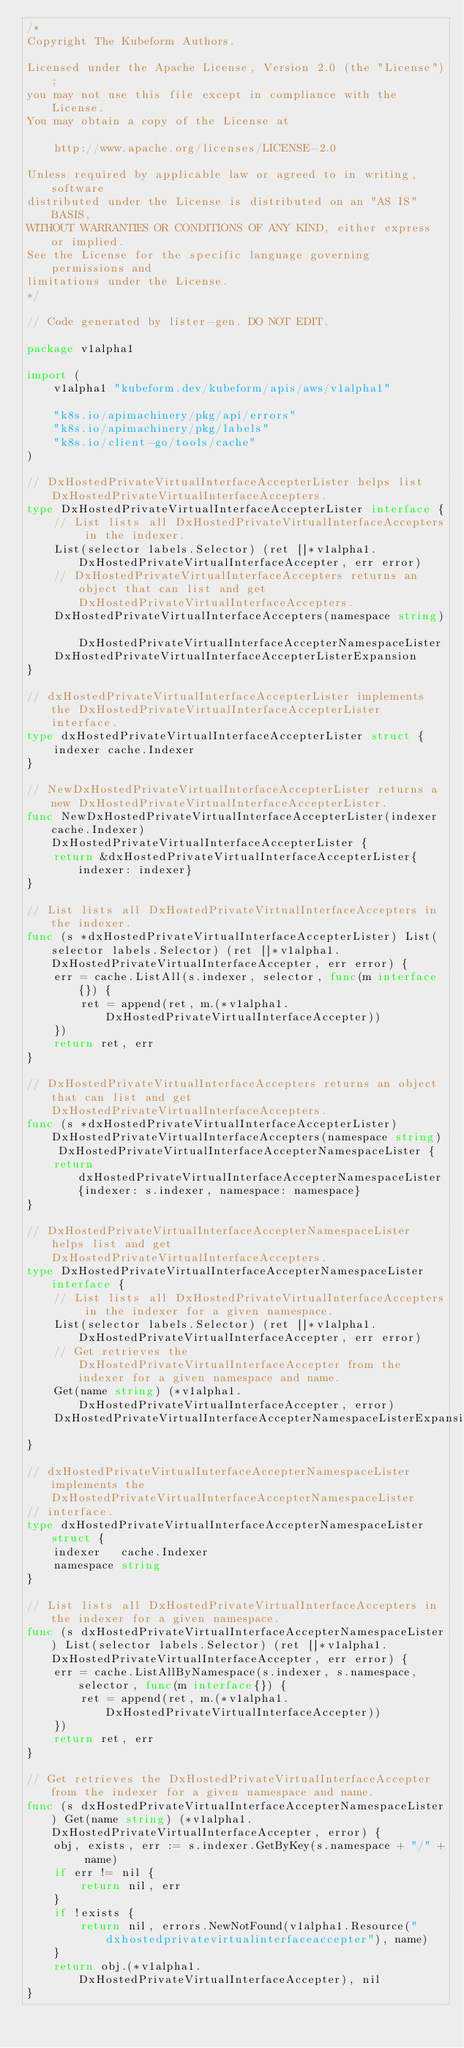<code> <loc_0><loc_0><loc_500><loc_500><_Go_>/*
Copyright The Kubeform Authors.

Licensed under the Apache License, Version 2.0 (the "License");
you may not use this file except in compliance with the License.
You may obtain a copy of the License at

    http://www.apache.org/licenses/LICENSE-2.0

Unless required by applicable law or agreed to in writing, software
distributed under the License is distributed on an "AS IS" BASIS,
WITHOUT WARRANTIES OR CONDITIONS OF ANY KIND, either express or implied.
See the License for the specific language governing permissions and
limitations under the License.
*/

// Code generated by lister-gen. DO NOT EDIT.

package v1alpha1

import (
	v1alpha1 "kubeform.dev/kubeform/apis/aws/v1alpha1"

	"k8s.io/apimachinery/pkg/api/errors"
	"k8s.io/apimachinery/pkg/labels"
	"k8s.io/client-go/tools/cache"
)

// DxHostedPrivateVirtualInterfaceAccepterLister helps list DxHostedPrivateVirtualInterfaceAccepters.
type DxHostedPrivateVirtualInterfaceAccepterLister interface {
	// List lists all DxHostedPrivateVirtualInterfaceAccepters in the indexer.
	List(selector labels.Selector) (ret []*v1alpha1.DxHostedPrivateVirtualInterfaceAccepter, err error)
	// DxHostedPrivateVirtualInterfaceAccepters returns an object that can list and get DxHostedPrivateVirtualInterfaceAccepters.
	DxHostedPrivateVirtualInterfaceAccepters(namespace string) DxHostedPrivateVirtualInterfaceAccepterNamespaceLister
	DxHostedPrivateVirtualInterfaceAccepterListerExpansion
}

// dxHostedPrivateVirtualInterfaceAccepterLister implements the DxHostedPrivateVirtualInterfaceAccepterLister interface.
type dxHostedPrivateVirtualInterfaceAccepterLister struct {
	indexer cache.Indexer
}

// NewDxHostedPrivateVirtualInterfaceAccepterLister returns a new DxHostedPrivateVirtualInterfaceAccepterLister.
func NewDxHostedPrivateVirtualInterfaceAccepterLister(indexer cache.Indexer) DxHostedPrivateVirtualInterfaceAccepterLister {
	return &dxHostedPrivateVirtualInterfaceAccepterLister{indexer: indexer}
}

// List lists all DxHostedPrivateVirtualInterfaceAccepters in the indexer.
func (s *dxHostedPrivateVirtualInterfaceAccepterLister) List(selector labels.Selector) (ret []*v1alpha1.DxHostedPrivateVirtualInterfaceAccepter, err error) {
	err = cache.ListAll(s.indexer, selector, func(m interface{}) {
		ret = append(ret, m.(*v1alpha1.DxHostedPrivateVirtualInterfaceAccepter))
	})
	return ret, err
}

// DxHostedPrivateVirtualInterfaceAccepters returns an object that can list and get DxHostedPrivateVirtualInterfaceAccepters.
func (s *dxHostedPrivateVirtualInterfaceAccepterLister) DxHostedPrivateVirtualInterfaceAccepters(namespace string) DxHostedPrivateVirtualInterfaceAccepterNamespaceLister {
	return dxHostedPrivateVirtualInterfaceAccepterNamespaceLister{indexer: s.indexer, namespace: namespace}
}

// DxHostedPrivateVirtualInterfaceAccepterNamespaceLister helps list and get DxHostedPrivateVirtualInterfaceAccepters.
type DxHostedPrivateVirtualInterfaceAccepterNamespaceLister interface {
	// List lists all DxHostedPrivateVirtualInterfaceAccepters in the indexer for a given namespace.
	List(selector labels.Selector) (ret []*v1alpha1.DxHostedPrivateVirtualInterfaceAccepter, err error)
	// Get retrieves the DxHostedPrivateVirtualInterfaceAccepter from the indexer for a given namespace and name.
	Get(name string) (*v1alpha1.DxHostedPrivateVirtualInterfaceAccepter, error)
	DxHostedPrivateVirtualInterfaceAccepterNamespaceListerExpansion
}

// dxHostedPrivateVirtualInterfaceAccepterNamespaceLister implements the DxHostedPrivateVirtualInterfaceAccepterNamespaceLister
// interface.
type dxHostedPrivateVirtualInterfaceAccepterNamespaceLister struct {
	indexer   cache.Indexer
	namespace string
}

// List lists all DxHostedPrivateVirtualInterfaceAccepters in the indexer for a given namespace.
func (s dxHostedPrivateVirtualInterfaceAccepterNamespaceLister) List(selector labels.Selector) (ret []*v1alpha1.DxHostedPrivateVirtualInterfaceAccepter, err error) {
	err = cache.ListAllByNamespace(s.indexer, s.namespace, selector, func(m interface{}) {
		ret = append(ret, m.(*v1alpha1.DxHostedPrivateVirtualInterfaceAccepter))
	})
	return ret, err
}

// Get retrieves the DxHostedPrivateVirtualInterfaceAccepter from the indexer for a given namespace and name.
func (s dxHostedPrivateVirtualInterfaceAccepterNamespaceLister) Get(name string) (*v1alpha1.DxHostedPrivateVirtualInterfaceAccepter, error) {
	obj, exists, err := s.indexer.GetByKey(s.namespace + "/" + name)
	if err != nil {
		return nil, err
	}
	if !exists {
		return nil, errors.NewNotFound(v1alpha1.Resource("dxhostedprivatevirtualinterfaceaccepter"), name)
	}
	return obj.(*v1alpha1.DxHostedPrivateVirtualInterfaceAccepter), nil
}
</code> 